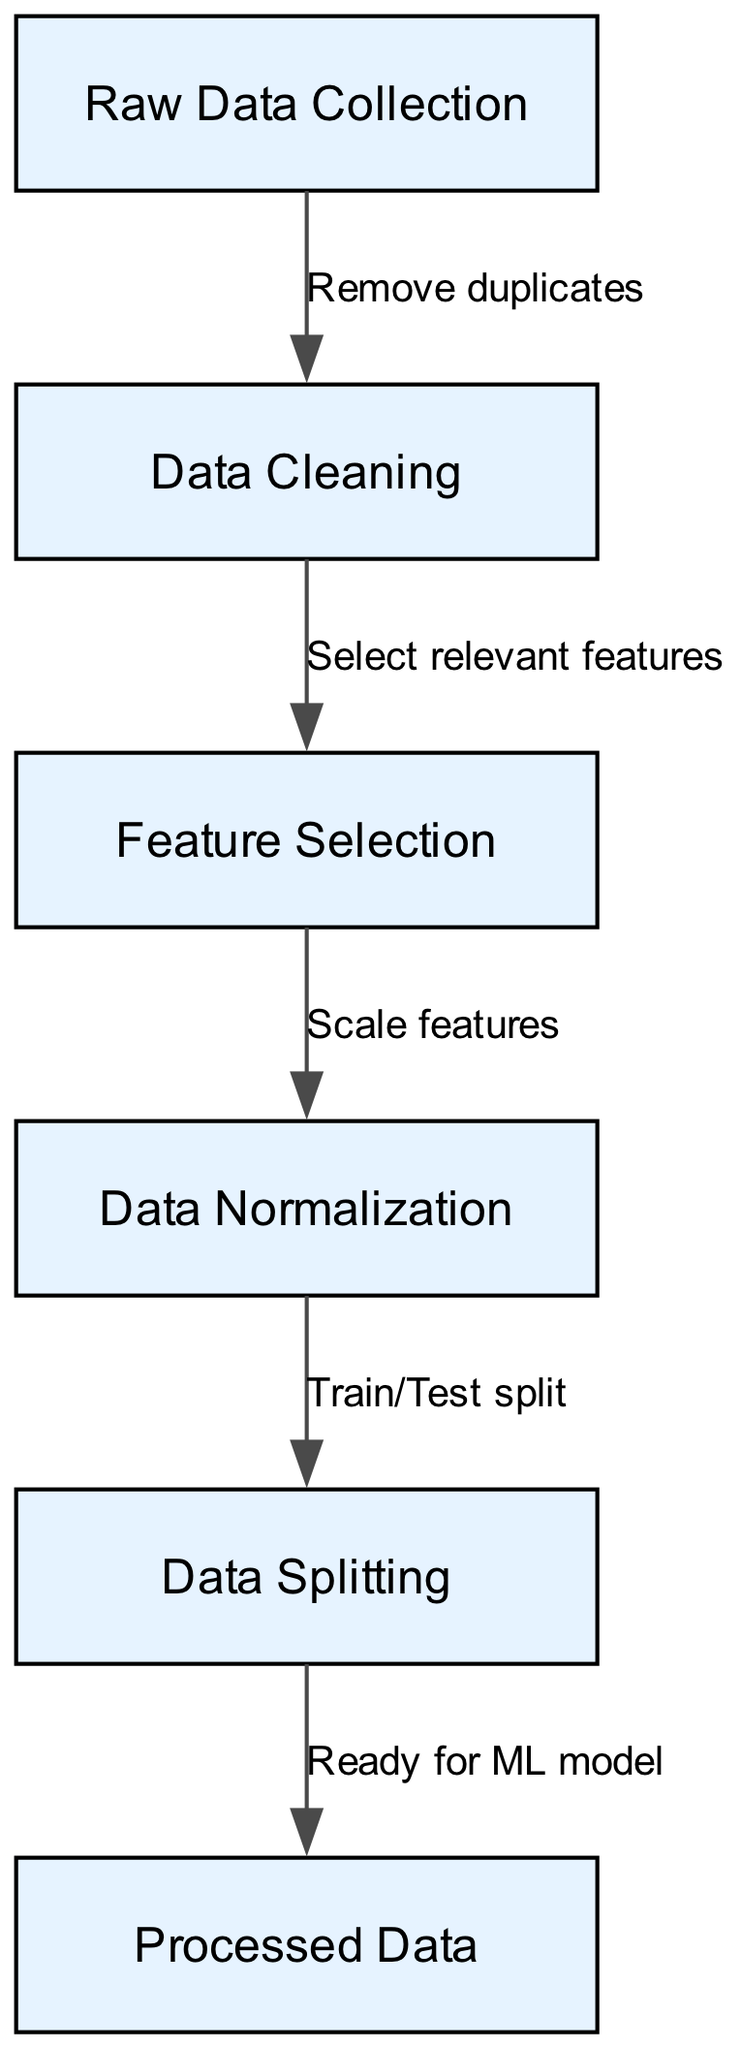What is the first step in the data preprocessing pipeline? The diagram indicates that the first node is "Raw Data Collection," which represents the initial step in the process.
Answer: Raw Data Collection How many nodes are there in the diagram? Upon counting the nodes listed in the diagram, there are a total of six nodes present: Raw Data Collection, Data Cleaning, Feature Selection, Data Normalization, Data Splitting, and Processed Data.
Answer: 6 What comes after data cleaning in the pipeline? The flow from the node "Data Cleaning" leads directly to the next node, which is "Feature Selection." This indicates that after cleaning the data, the next task is to select relevant features.
Answer: Feature Selection Which node directly leads to the processed data? The last action before reaching the "Processed Data" node comes from "Data Splitting," indicating that the data must be split into different sets before it can be prepared for modeling.
Answer: Data Splitting What action is performed between feature selection and normalization? The edge connecting "Feature Selection" to "Data Normalization" indicates the action taken is to "Scale features," meaning that feature scaling occurs during this transition.
Answer: Scale features What is the relationship between raw data collection and data cleaning? The edge from "Raw Data Collection" to "Data Cleaning" is labeled "Remove duplicates," showing that the cleaning process involves removing any duplicate entries from the collected data.
Answer: Remove duplicates What step must be completed before readying data for the machine learning model? The step that needs to occur before the data is deemed "Ready for ML model" is the "Data Splitting," signaling that the dataset must be appropriately split into training and testing sets.
Answer: Data Splitting What type of diagram is represented here? This is a flow chart, which visually represents the sequential steps involved in the data preprocessing pipeline for machine learning projects.
Answer: Flow chart 